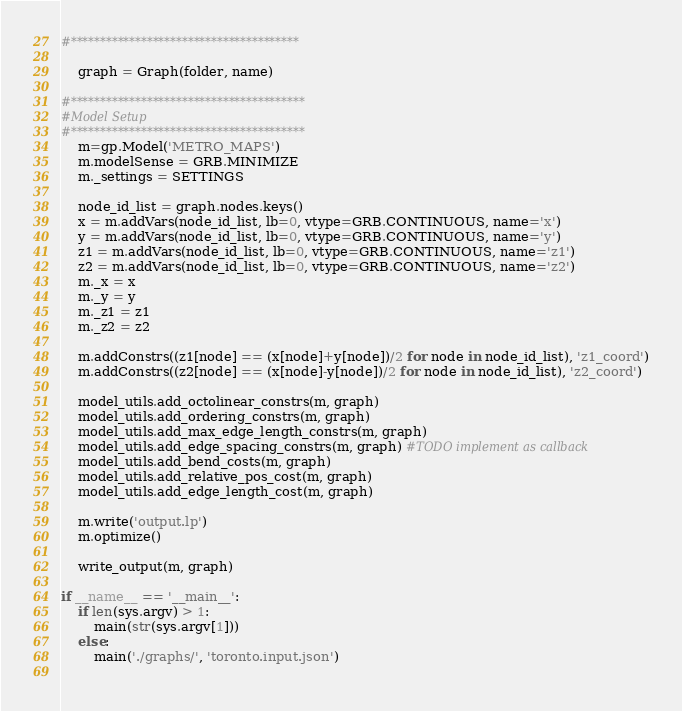Convert code to text. <code><loc_0><loc_0><loc_500><loc_500><_Python_>#***************************************  
    
    graph = Graph(folder, name)

#****************************************
#Model Setup
#****************************************
    m=gp.Model('METRO_MAPS')
    m.modelSense = GRB.MINIMIZE
    m._settings = SETTINGS

    node_id_list = graph.nodes.keys()
    x = m.addVars(node_id_list, lb=0, vtype=GRB.CONTINUOUS, name='x')
    y = m.addVars(node_id_list, lb=0, vtype=GRB.CONTINUOUS, name='y')
    z1 = m.addVars(node_id_list, lb=0, vtype=GRB.CONTINUOUS, name='z1')
    z2 = m.addVars(node_id_list, lb=0, vtype=GRB.CONTINUOUS, name='z2')
    m._x = x
    m._y = y
    m._z1 = z1
    m._z2 = z2

    m.addConstrs((z1[node] == (x[node]+y[node])/2 for node in node_id_list), 'z1_coord')
    m.addConstrs((z2[node] == (x[node]-y[node])/2 for node in node_id_list), 'z2_coord')

    model_utils.add_octolinear_constrs(m, graph)
    model_utils.add_ordering_constrs(m, graph)
    model_utils.add_max_edge_length_constrs(m, graph)
    model_utils.add_edge_spacing_constrs(m, graph) #TODO implement as callback
    model_utils.add_bend_costs(m, graph)
    model_utils.add_relative_pos_cost(m, graph)
    model_utils.add_edge_length_cost(m, graph)

    m.write('output.lp')
    m.optimize()

    write_output(m, graph)

if __name__ == '__main__':
    if len(sys.argv) > 1:
        main(str(sys.argv[1]))
    else:
        main('./graphs/', 'toronto.input.json')
        </code> 